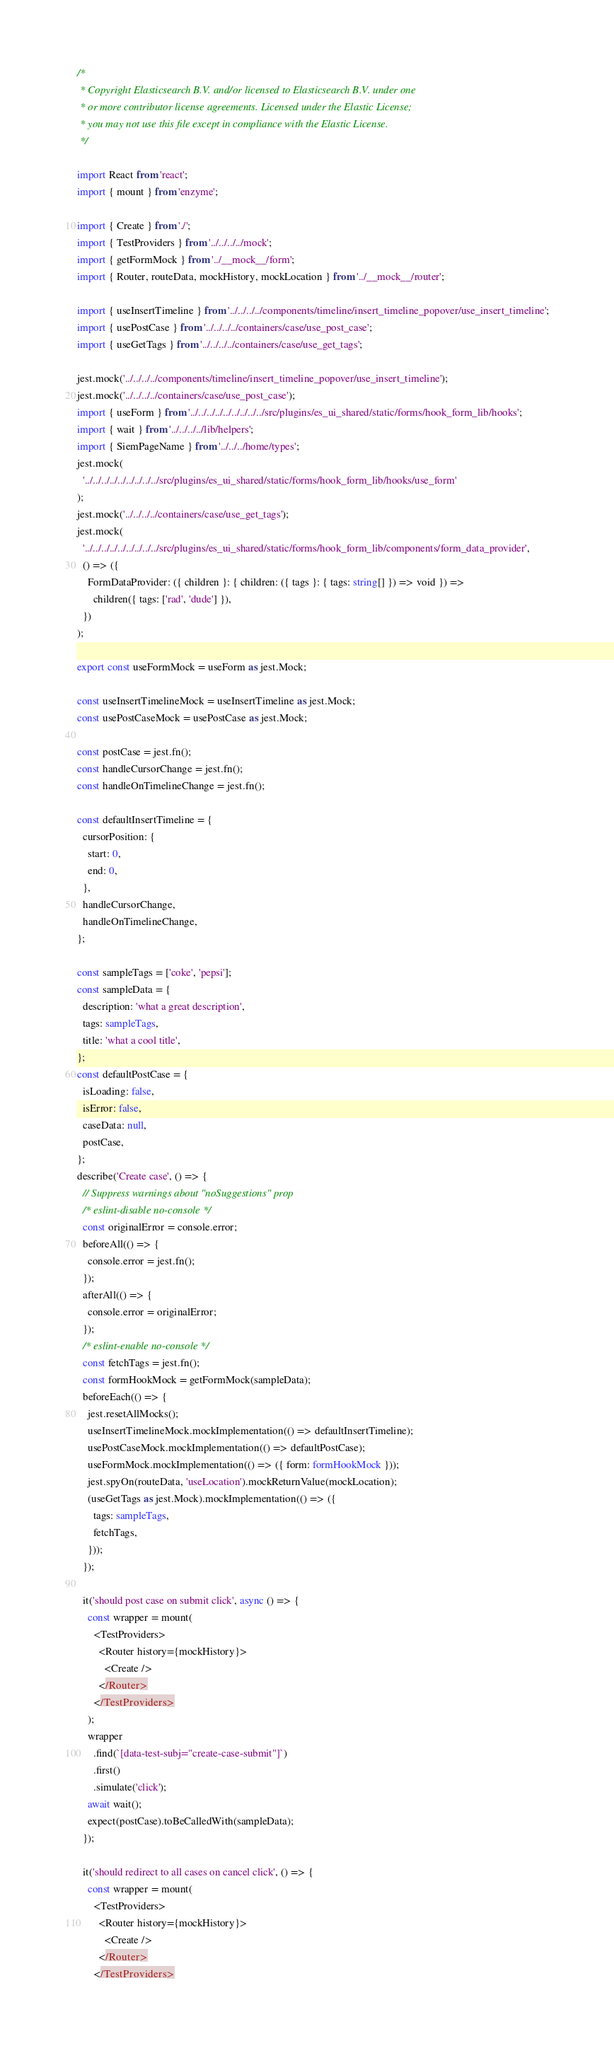Convert code to text. <code><loc_0><loc_0><loc_500><loc_500><_TypeScript_>/*
 * Copyright Elasticsearch B.V. and/or licensed to Elasticsearch B.V. under one
 * or more contributor license agreements. Licensed under the Elastic License;
 * you may not use this file except in compliance with the Elastic License.
 */

import React from 'react';
import { mount } from 'enzyme';

import { Create } from './';
import { TestProviders } from '../../../../mock';
import { getFormMock } from '../__mock__/form';
import { Router, routeData, mockHistory, mockLocation } from '../__mock__/router';

import { useInsertTimeline } from '../../../../components/timeline/insert_timeline_popover/use_insert_timeline';
import { usePostCase } from '../../../../containers/case/use_post_case';
import { useGetTags } from '../../../../containers/case/use_get_tags';

jest.mock('../../../../components/timeline/insert_timeline_popover/use_insert_timeline');
jest.mock('../../../../containers/case/use_post_case');
import { useForm } from '../../../../../../../../../src/plugins/es_ui_shared/static/forms/hook_form_lib/hooks';
import { wait } from '../../../../lib/helpers';
import { SiemPageName } from '../../../home/types';
jest.mock(
  '../../../../../../../../../src/plugins/es_ui_shared/static/forms/hook_form_lib/hooks/use_form'
);
jest.mock('../../../../containers/case/use_get_tags');
jest.mock(
  '../../../../../../../../../src/plugins/es_ui_shared/static/forms/hook_form_lib/components/form_data_provider',
  () => ({
    FormDataProvider: ({ children }: { children: ({ tags }: { tags: string[] }) => void }) =>
      children({ tags: ['rad', 'dude'] }),
  })
);

export const useFormMock = useForm as jest.Mock;

const useInsertTimelineMock = useInsertTimeline as jest.Mock;
const usePostCaseMock = usePostCase as jest.Mock;

const postCase = jest.fn();
const handleCursorChange = jest.fn();
const handleOnTimelineChange = jest.fn();

const defaultInsertTimeline = {
  cursorPosition: {
    start: 0,
    end: 0,
  },
  handleCursorChange,
  handleOnTimelineChange,
};

const sampleTags = ['coke', 'pepsi'];
const sampleData = {
  description: 'what a great description',
  tags: sampleTags,
  title: 'what a cool title',
};
const defaultPostCase = {
  isLoading: false,
  isError: false,
  caseData: null,
  postCase,
};
describe('Create case', () => {
  // Suppress warnings about "noSuggestions" prop
  /* eslint-disable no-console */
  const originalError = console.error;
  beforeAll(() => {
    console.error = jest.fn();
  });
  afterAll(() => {
    console.error = originalError;
  });
  /* eslint-enable no-console */
  const fetchTags = jest.fn();
  const formHookMock = getFormMock(sampleData);
  beforeEach(() => {
    jest.resetAllMocks();
    useInsertTimelineMock.mockImplementation(() => defaultInsertTimeline);
    usePostCaseMock.mockImplementation(() => defaultPostCase);
    useFormMock.mockImplementation(() => ({ form: formHookMock }));
    jest.spyOn(routeData, 'useLocation').mockReturnValue(mockLocation);
    (useGetTags as jest.Mock).mockImplementation(() => ({
      tags: sampleTags,
      fetchTags,
    }));
  });

  it('should post case on submit click', async () => {
    const wrapper = mount(
      <TestProviders>
        <Router history={mockHistory}>
          <Create />
        </Router>
      </TestProviders>
    );
    wrapper
      .find(`[data-test-subj="create-case-submit"]`)
      .first()
      .simulate('click');
    await wait();
    expect(postCase).toBeCalledWith(sampleData);
  });

  it('should redirect to all cases on cancel click', () => {
    const wrapper = mount(
      <TestProviders>
        <Router history={mockHistory}>
          <Create />
        </Router>
      </TestProviders></code> 